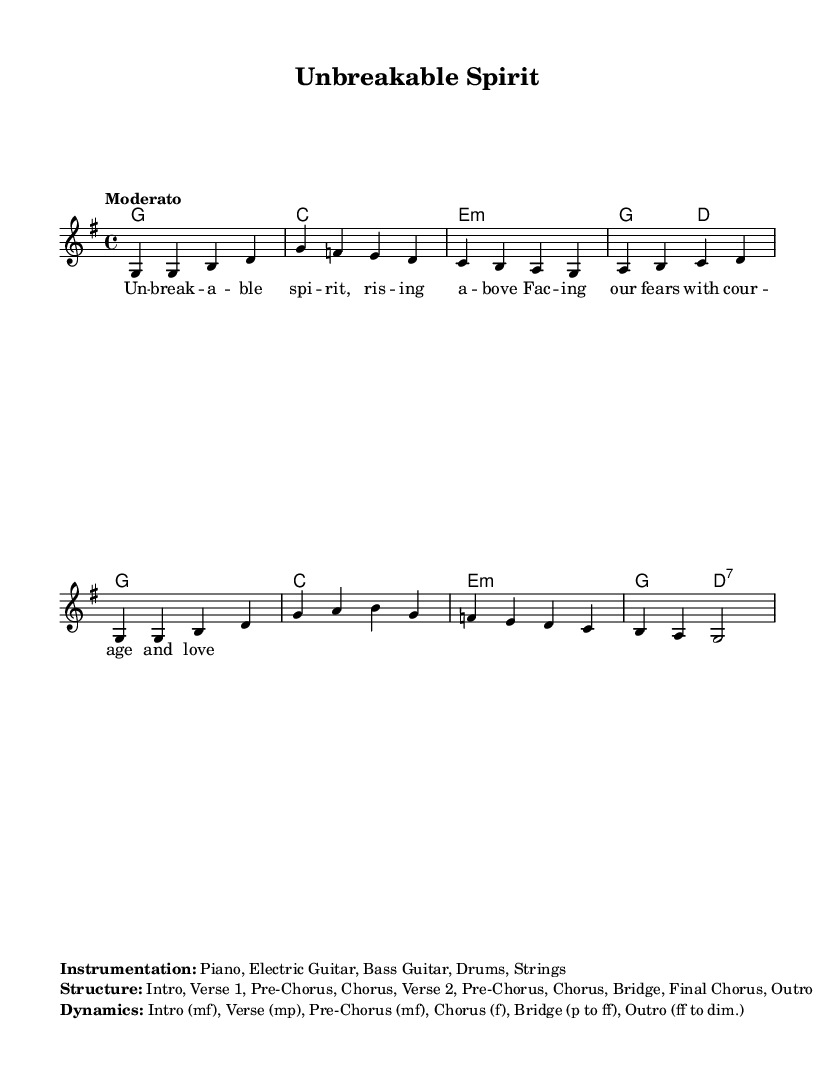What is the key signature of this music? The key signature is G major, which has one sharp (F#). This can be identified by looking at the beginning of the staff where the sharps are indicated.
Answer: G major What is the time signature of this music? The time signature is 4/4, which means there are four beats in a measure and the quarter note gets one beat. This is commonly seen in the top part of the score.
Answer: 4/4 What is the tempo marking of this music? The tempo marking is "Moderato," indicating a moderate speed. This is typically noted at the beginning of the piece and guides the performer on the intended pace.
Answer: Moderato How many measures are in the piece? To find the number of measures, count the vertical lines that separate the musical notes; in this case, there are 8 measures.
Answer: 8 What musical instruments are included in the instrumentation? The instrumentation listed includes Piano, Electric Guitar, Bass Guitar, Drums, and Strings. This information is provided in the markup section of the score that describes the arrangement.
Answer: Piano, Electric Guitar, Bass Guitar, Drums, Strings What is the dynamic marking for the bridge section? The dynamic marking for the bridge section is "p to ff," indicating it should start softly (piano) and build up to very loud (fortissimo). This marking enhances the emotional impact of the music.
Answer: p to ff What is the structure of the song? The structure of the song is: Intro, Verse 1, Pre-Chorus, Chorus, Verse 2, Pre-Chorus, Chorus, Bridge, Final Chorus, Outro, which outlines the arrangement of the various sections of the music.
Answer: Intro, Verse 1, Pre-Chorus, Chorus, Verse 2, Pre-Chorus, Chorus, Bridge, Final Chorus, Outro 